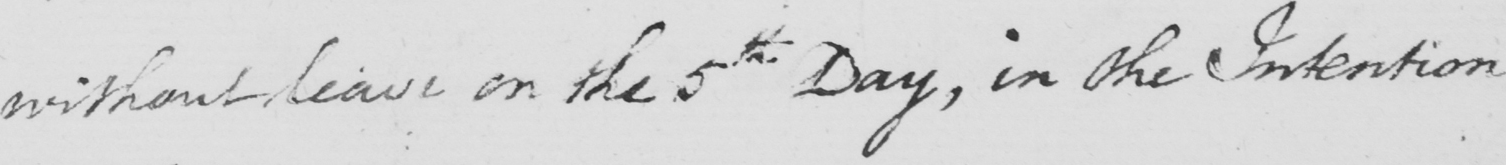What is written in this line of handwriting? without leave on the 5th Day , in the Intention 